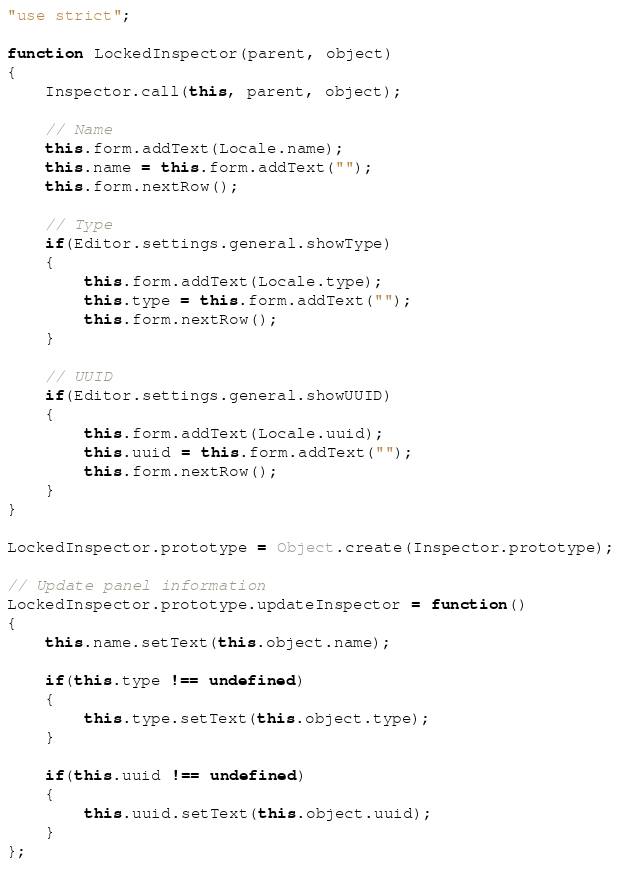Convert code to text. <code><loc_0><loc_0><loc_500><loc_500><_JavaScript_>"use strict";

function LockedInspector(parent, object)
{
	Inspector.call(this, parent, object);

	// Name
	this.form.addText(Locale.name);
	this.name = this.form.addText("");
	this.form.nextRow();

	// Type
	if(Editor.settings.general.showType)
	{
		this.form.addText(Locale.type);
		this.type = this.form.addText("");
		this.form.nextRow();
	}

	// UUID
	if(Editor.settings.general.showUUID)
	{
		this.form.addText(Locale.uuid);
		this.uuid = this.form.addText("");
		this.form.nextRow();
	}
}

LockedInspector.prototype = Object.create(Inspector.prototype);

// Update panel information
LockedInspector.prototype.updateInspector = function()
{
	this.name.setText(this.object.name);
	
	if(this.type !== undefined)
	{
		this.type.setText(this.object.type);
	}

	if(this.uuid !== undefined)
	{
		this.uuid.setText(this.object.uuid);
	}
};</code> 